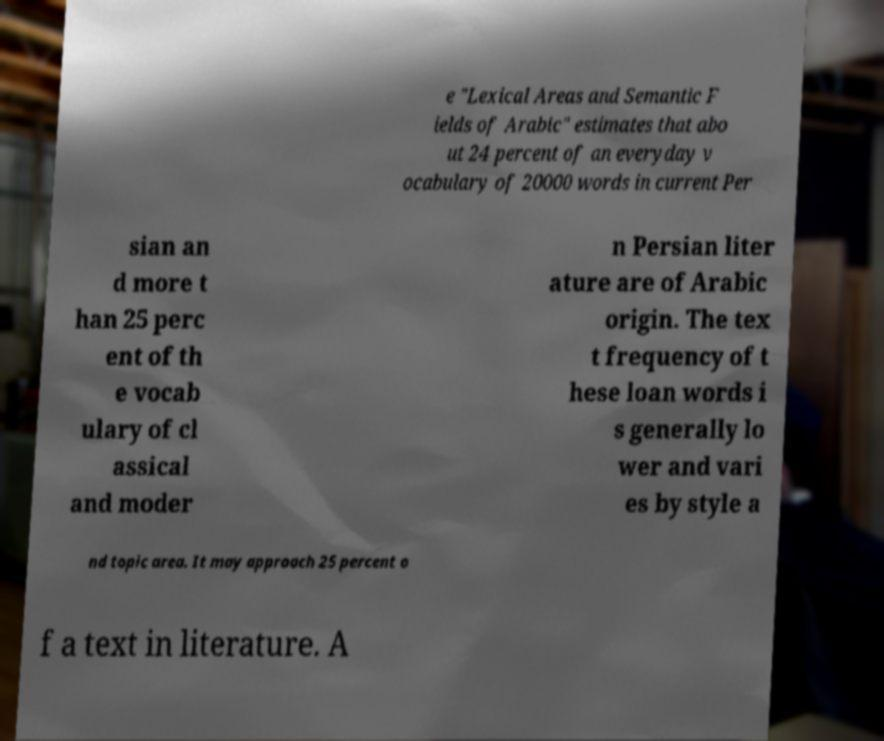Could you assist in decoding the text presented in this image and type it out clearly? e "Lexical Areas and Semantic F ields of Arabic" estimates that abo ut 24 percent of an everyday v ocabulary of 20000 words in current Per sian an d more t han 25 perc ent of th e vocab ulary of cl assical and moder n Persian liter ature are of Arabic origin. The tex t frequency of t hese loan words i s generally lo wer and vari es by style a nd topic area. It may approach 25 percent o f a text in literature. A 